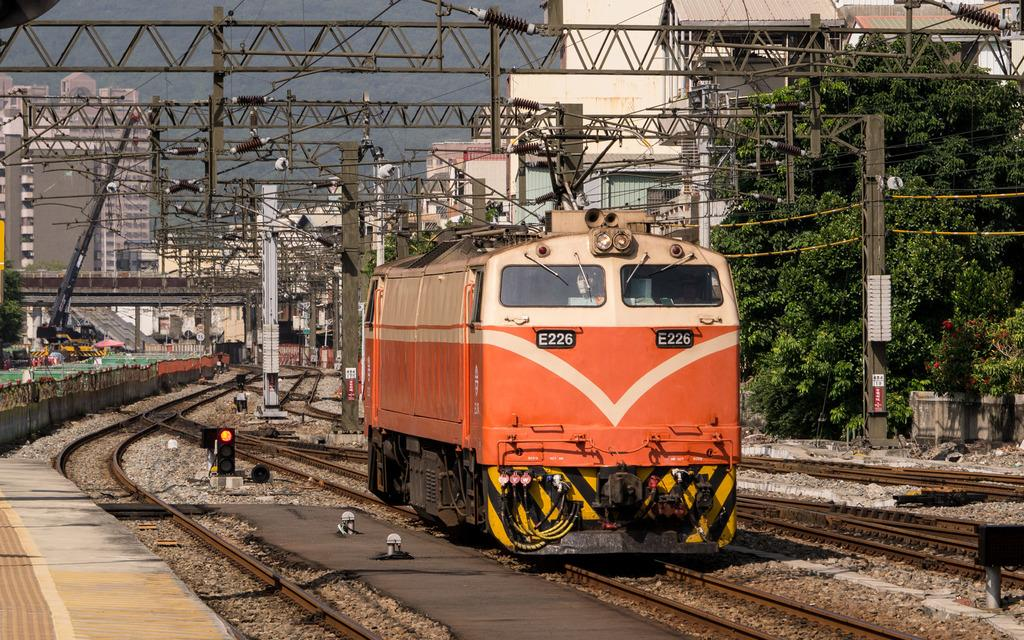<image>
Render a clear and concise summary of the photo. A peach and white colored train car with the number E226 on the front of it. 